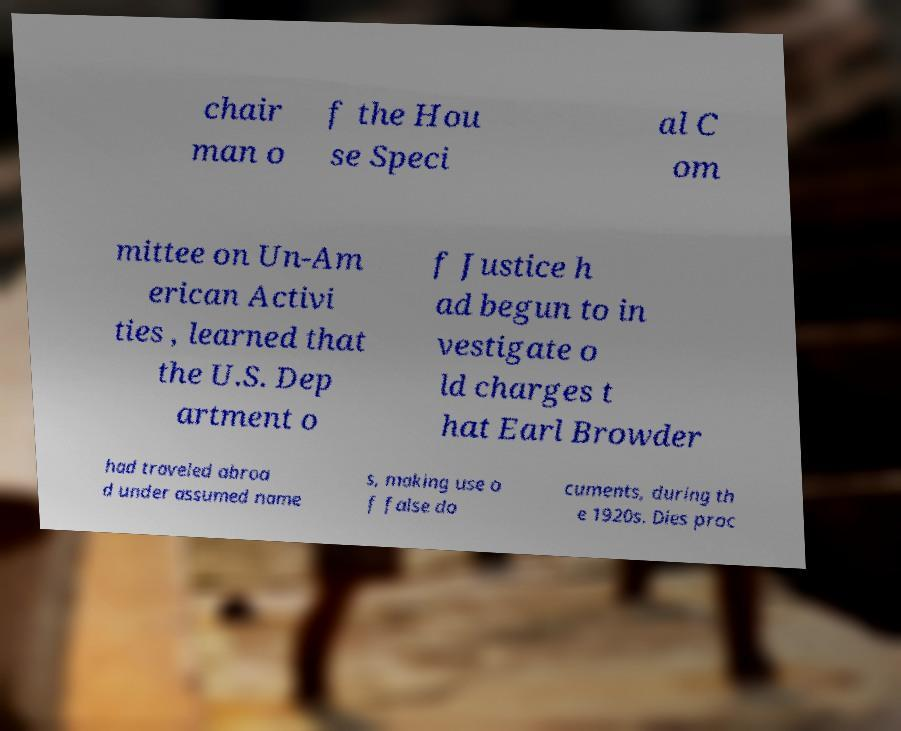I need the written content from this picture converted into text. Can you do that? chair man o f the Hou se Speci al C om mittee on Un-Am erican Activi ties , learned that the U.S. Dep artment o f Justice h ad begun to in vestigate o ld charges t hat Earl Browder had traveled abroa d under assumed name s, making use o f false do cuments, during th e 1920s. Dies proc 